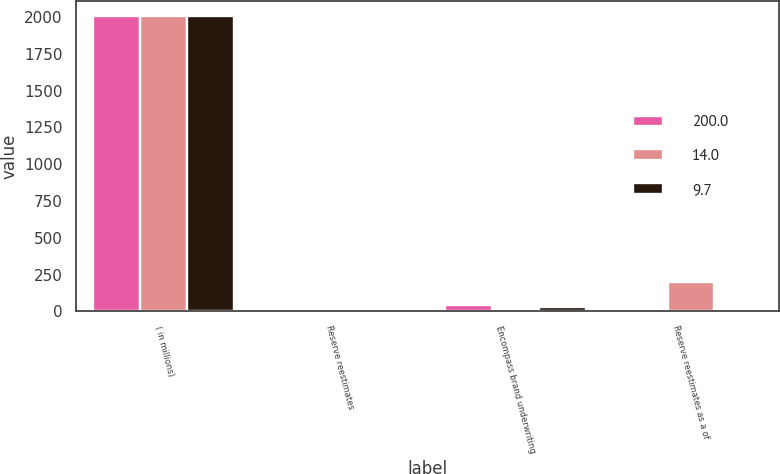Convert chart. <chart><loc_0><loc_0><loc_500><loc_500><stacked_bar_chart><ecel><fcel>( in millions)<fcel>Reserve reestimates<fcel>Encompass brand underwriting<fcel>Reserve reestimates as a of<nl><fcel>200<fcel>2010<fcel>6<fcel>43<fcel>14<nl><fcel>14<fcel>2009<fcel>10<fcel>5<fcel>200<nl><fcel>9.7<fcel>2008<fcel>3<fcel>31<fcel>9.7<nl></chart> 